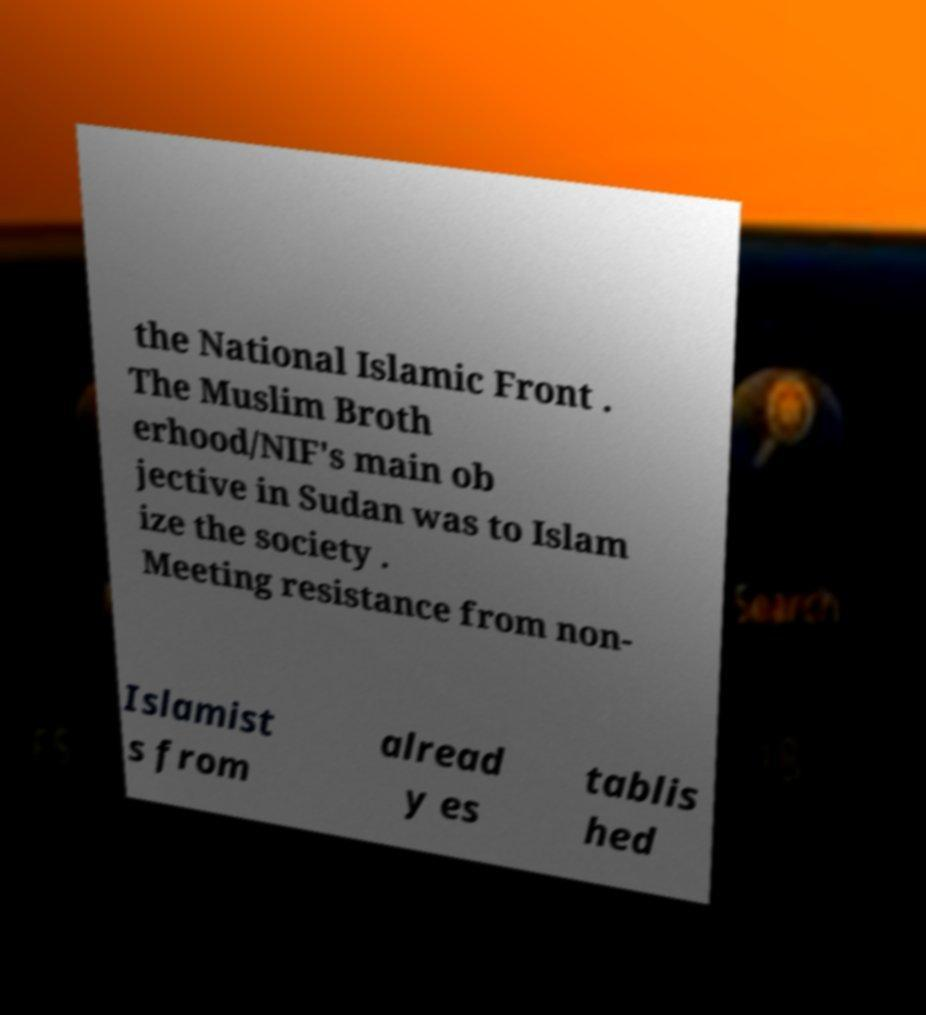Please identify and transcribe the text found in this image. the National Islamic Front . The Muslim Broth erhood/NIF's main ob jective in Sudan was to Islam ize the society . Meeting resistance from non- Islamist s from alread y es tablis hed 